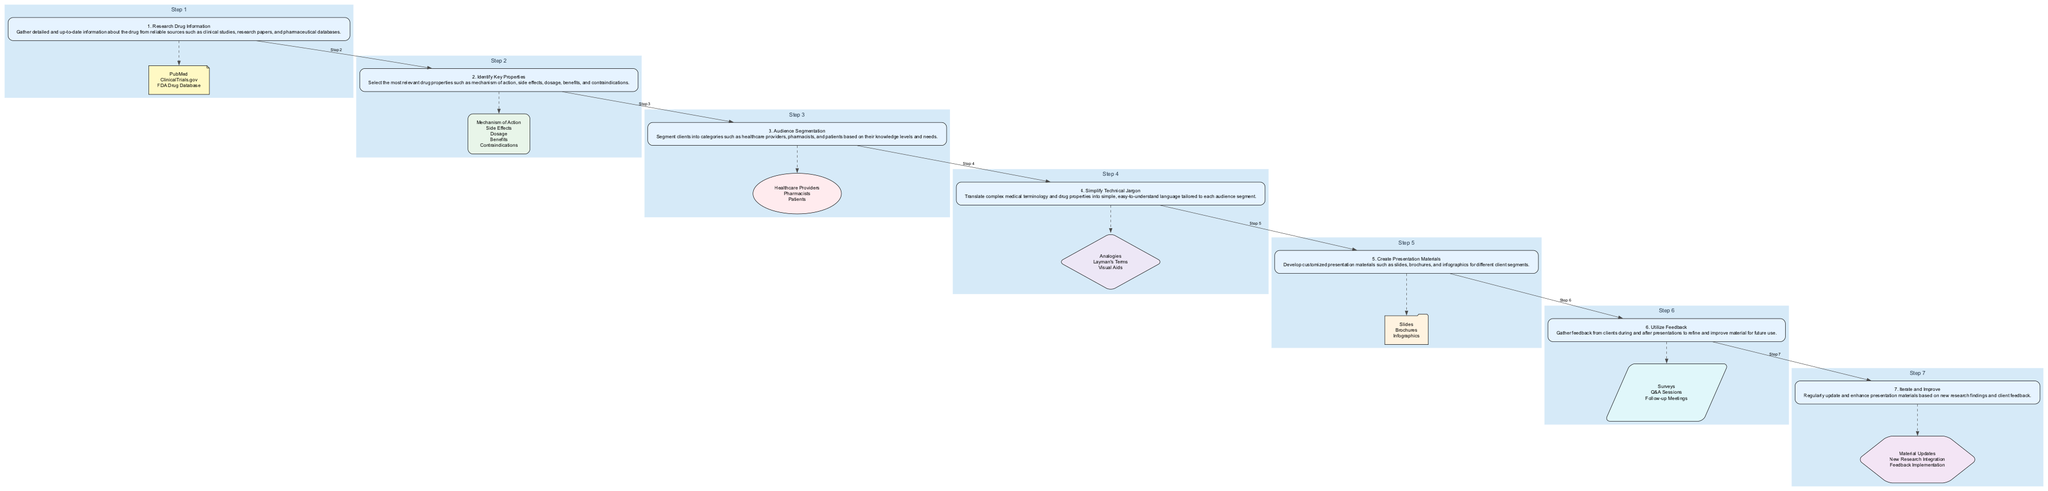What is the first step in the drug properties simplification process? The flowchart shows that the first step is labeled as "1. Research Drug Information," which describes gathering detailed and up-to-date information about the drug.
Answer: Research Drug Information How many audience segments are identified in the process? Within the diagram, step three mentions "Audience Segmentation" and lists three segments: Healthcare Providers, Pharmacists, and Patients. Therefore, this indicates there are three audience segments identified.
Answer: 3 Which materials are created in the fifth step? In step five, titled "Create Presentation Materials," the flowchart specifies that the materials developed include Slides, Brochures, and Infographics.
Answer: Slides, Brochures, Infographics What techniques are suggested for simplifying technical jargon? Step four of the flowchart highlights "Simplify Technical Jargon," which includes techniques such as Analogies, Layman's Terms, and Visual Aids, all aimed at making complex terms understandable.
Answer: Analogies, Layman's Terms, Visual Aids What follows the "Utilize Feedback" step? The diagram outlines a sequential flow, and following the "Utilize Feedback" step (step six), the next step in the process is "Iterate and Improve," which enhances materials based on feedback received.
Answer: Iterate and Improve 